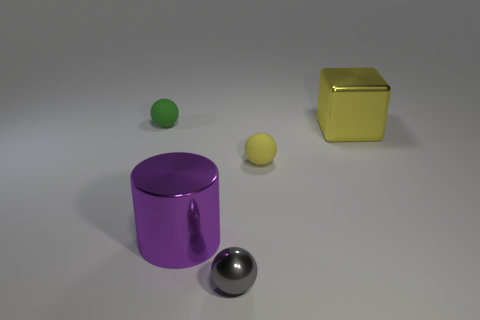What is the color of the small rubber ball that is to the right of the green matte object that is behind the large metal object on the right side of the tiny yellow object?
Offer a terse response. Yellow. Is the large yellow object made of the same material as the big thing on the left side of the large yellow object?
Your answer should be compact. Yes. What is the large yellow cube made of?
Keep it short and to the point. Metal. How many other objects are there of the same material as the small green sphere?
Give a very brief answer. 1. There is a tiny object that is both in front of the yellow metallic cube and behind the purple metallic object; what shape is it?
Your answer should be very brief. Sphere. What is the color of the cylinder that is made of the same material as the tiny gray ball?
Your response must be concise. Purple. Are there an equal number of big yellow things that are to the left of the small green rubber thing and large gray things?
Your answer should be very brief. Yes. What is the shape of the thing that is the same size as the purple cylinder?
Offer a terse response. Cube. How many other things are the same shape as the big purple object?
Your answer should be very brief. 0. There is a purple shiny cylinder; is its size the same as the sphere behind the large yellow object?
Keep it short and to the point. No. 